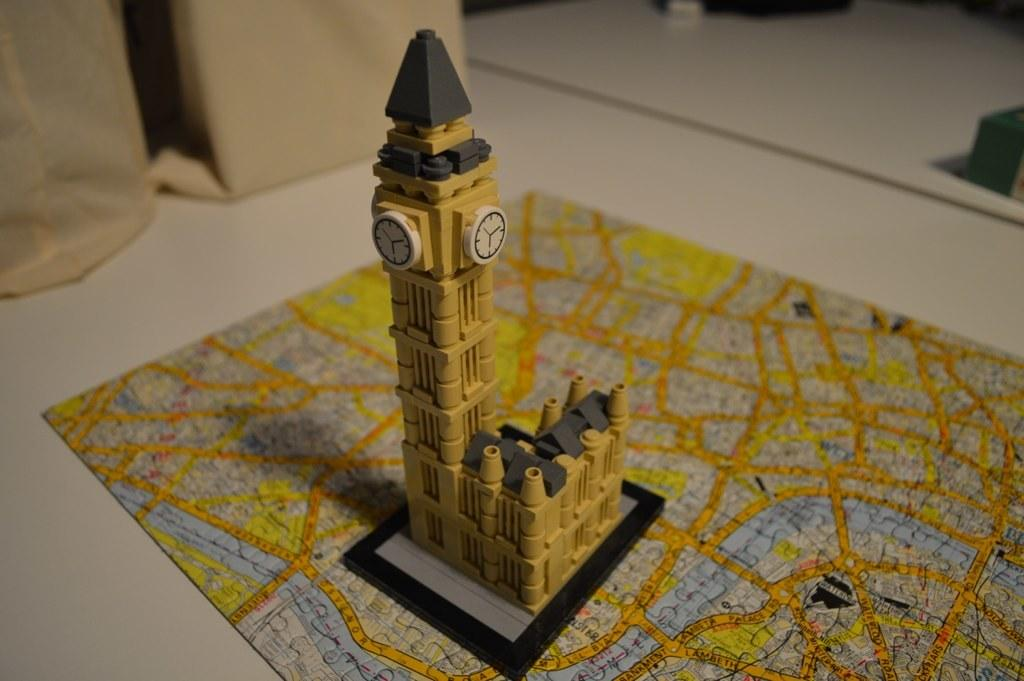What is the main subject of the image? The main subject of the image is a miniature of a clock tower. What is the context of the miniature in the image? The miniature is part of a jigsaw puzzle. What type of bags can be seen in the image? There are brown color bags in the image. On what surface are the brown bags placed? The brown bags are on a white color table. How does the duck in the image compare to the size of the clock tower miniature? There is no duck present in the image, so it cannot be compared to the size of the clock tower miniature. 